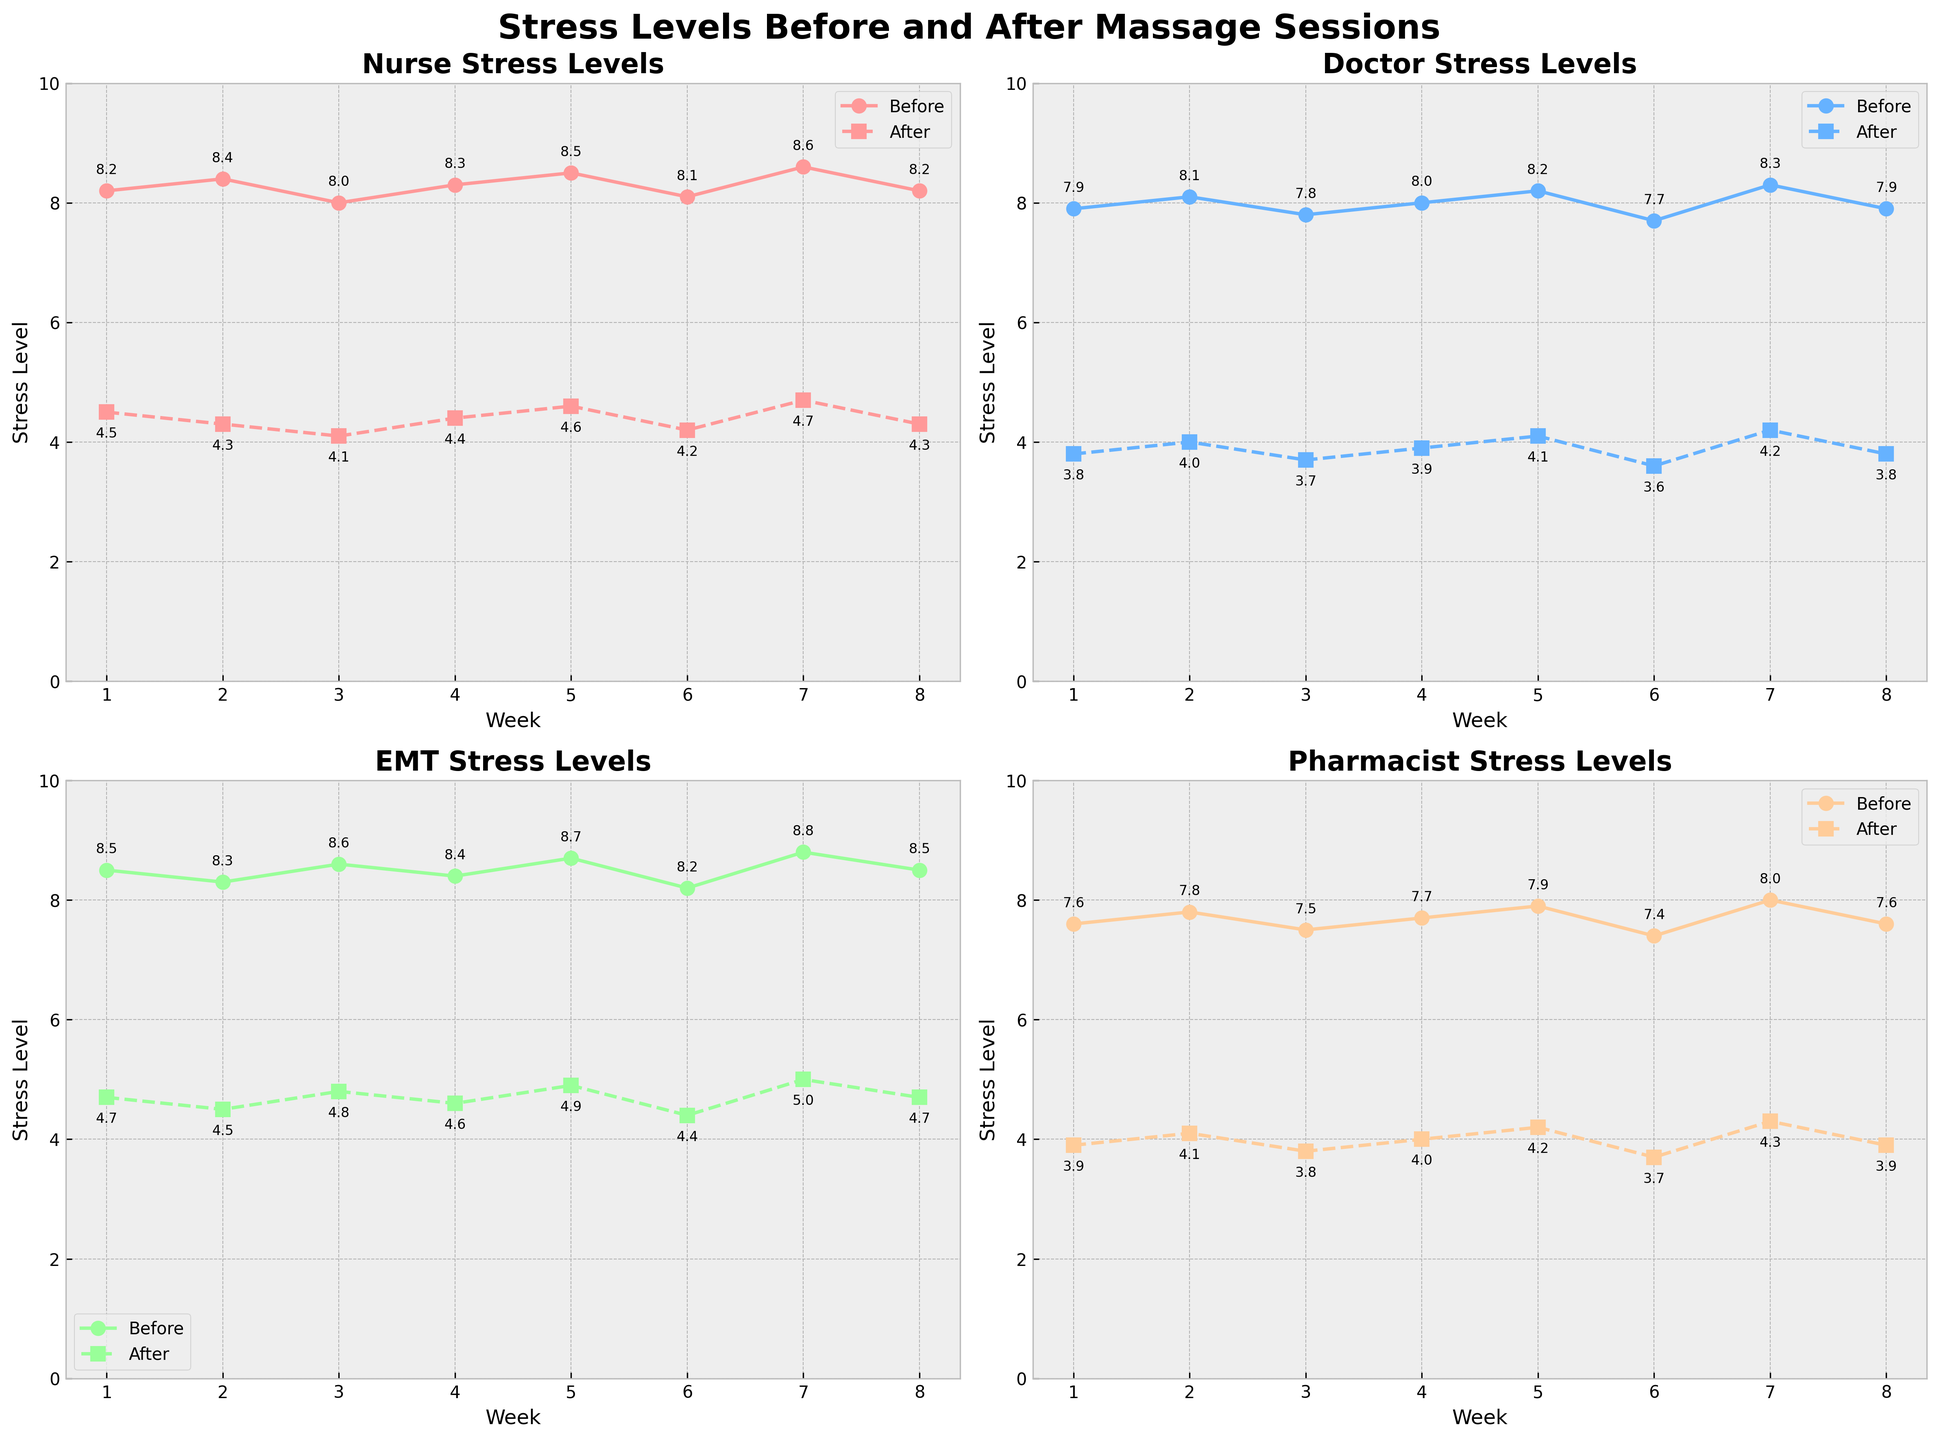What is the title of the figure? The title of the figure is displayed at the top of the plot, summarizing the overall content.
Answer: Stress Levels Before and After Massage Sessions What is the Y-axis label for the 'Nurse' subplot? The Y-axis label indicates the variable being measured on the vertical axis in the 'Nurse' subplot.
Answer: Stress Level Which professional category shows the largest difference in stress levels before and after the massage session in week 3? Subtract the 'After' value from the 'Before' value for each profession in week 3. The largest difference is the highest absolute value.
Answer: EMT What is the average stress level for doctors before the massage sessions over all weeks? Sum the 'Doctor_Before' values for all weeks, then divide by the number of weeks.
Answer: 8.0 Which professional category has the most consistent (least variable) stress levels after the massage sessions across all weeks? Calculate the variance or the range (max-min) of the 'After' values for each profession. The profession with the smallest variance or range is the most consistent.
Answer: Nurse In week 5, which profession reported the highest stress level before the massage sessions? Compare the 'Before' values for each profession in week 5 to determine the highest.
Answer: EMT How does the stress level for pharmacists after the massage session in week 6 compare to the stress level before the massage session in week 6? Subtract the 'Pharmacist_After' value from the 'Pharmacist_Before' value in week 6.
Answer: Decreased by 3.7 Are there any weeks where nurses' stress levels after the massage sessions were higher than doctors' stress levels before the massage sessions? Compare 'Nurse_After' values with 'Doctor_Before' values for each week.
Answer: No What is the overall trend in stress levels before and after the massage sessions for all professions? Observe the general direction of the lines for 'Before' and 'After' across all weeks for each profession. The 'Before' lines generally decrease after each session.
Answer: Decreasing trend Which week shows the smallest difference between before and after stress levels for EMTs? Subtract the 'After' value from the 'Before' value for EMTs in each week and find the smallest difference.
Answer: Week 6 